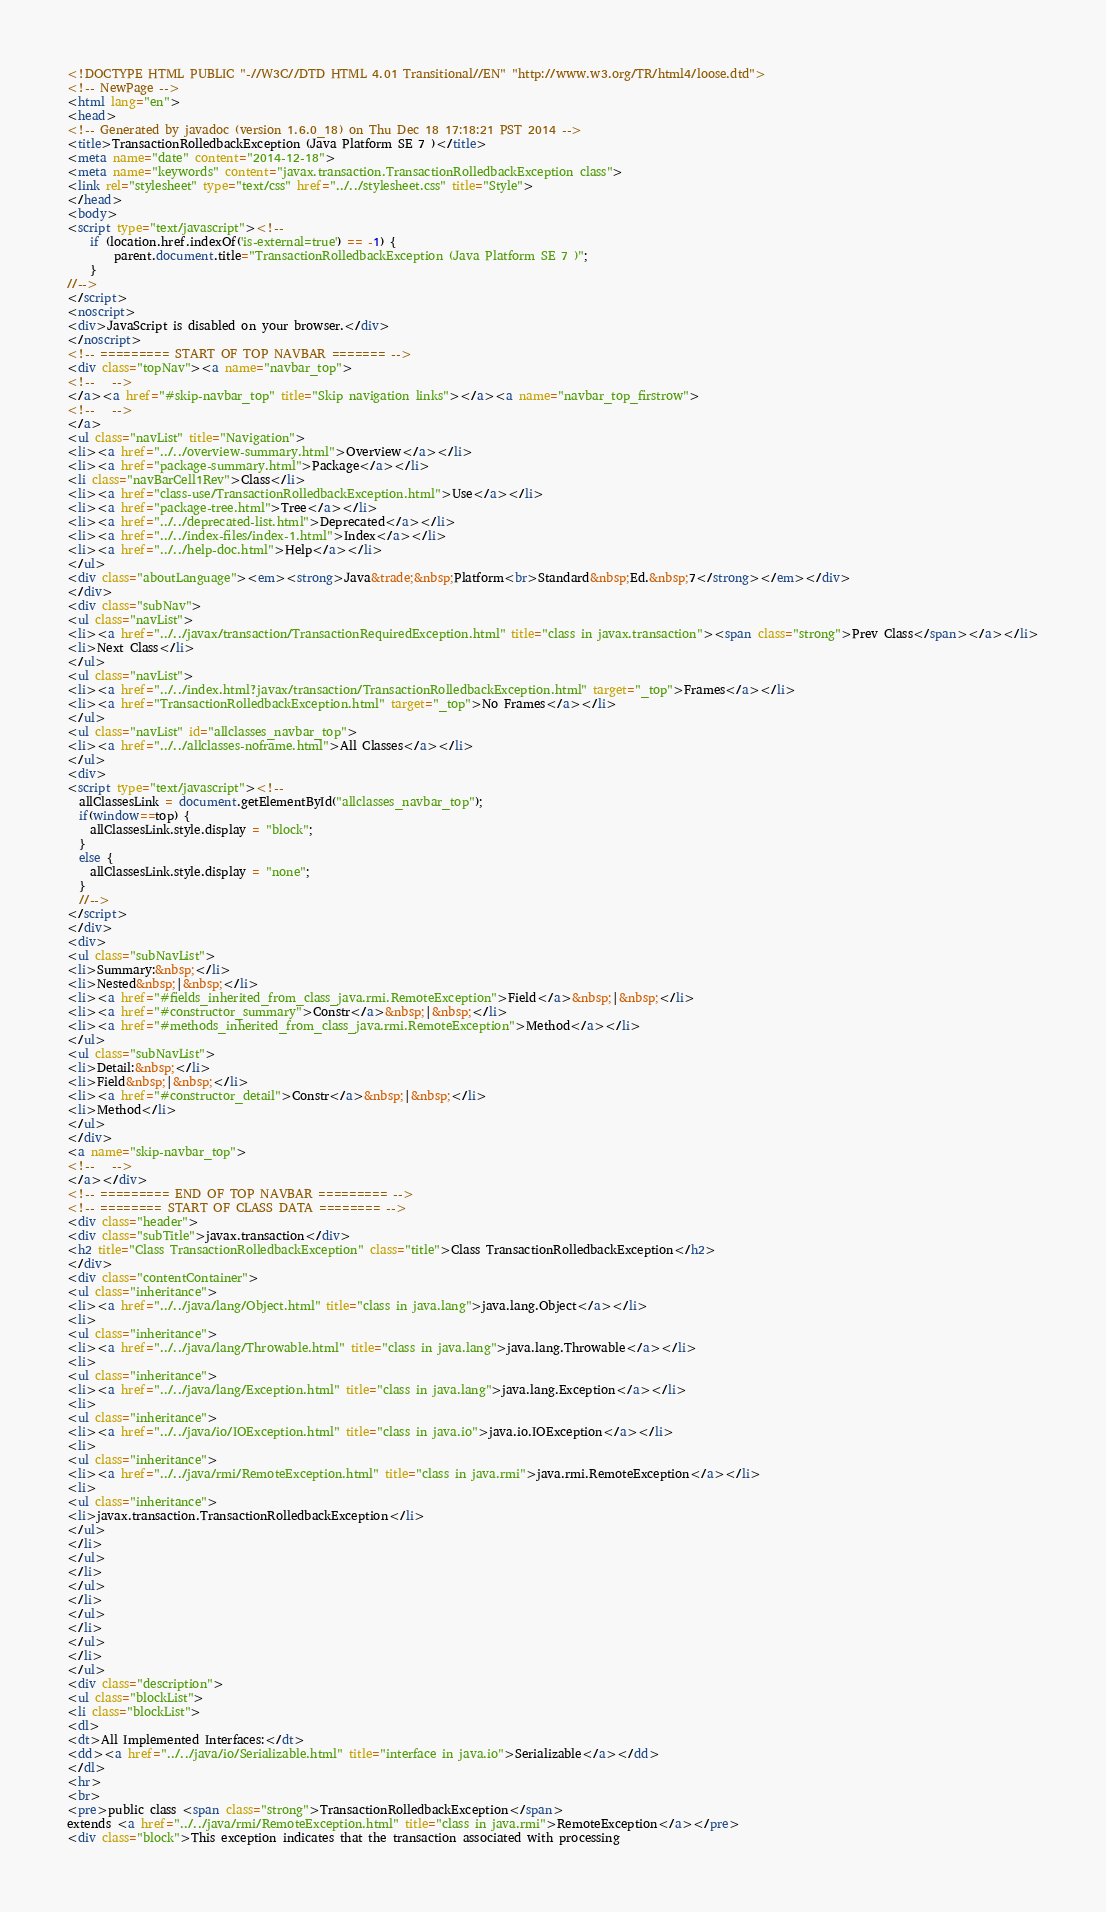Convert code to text. <code><loc_0><loc_0><loc_500><loc_500><_HTML_><!DOCTYPE HTML PUBLIC "-//W3C//DTD HTML 4.01 Transitional//EN" "http://www.w3.org/TR/html4/loose.dtd">
<!-- NewPage -->
<html lang="en">
<head>
<!-- Generated by javadoc (version 1.6.0_18) on Thu Dec 18 17:18:21 PST 2014 -->
<title>TransactionRolledbackException (Java Platform SE 7 )</title>
<meta name="date" content="2014-12-18">
<meta name="keywords" content="javax.transaction.TransactionRolledbackException class">
<link rel="stylesheet" type="text/css" href="../../stylesheet.css" title="Style">
</head>
<body>
<script type="text/javascript"><!--
    if (location.href.indexOf('is-external=true') == -1) {
        parent.document.title="TransactionRolledbackException (Java Platform SE 7 )";
    }
//-->
</script>
<noscript>
<div>JavaScript is disabled on your browser.</div>
</noscript>
<!-- ========= START OF TOP NAVBAR ======= -->
<div class="topNav"><a name="navbar_top">
<!--   -->
</a><a href="#skip-navbar_top" title="Skip navigation links"></a><a name="navbar_top_firstrow">
<!--   -->
</a>
<ul class="navList" title="Navigation">
<li><a href="../../overview-summary.html">Overview</a></li>
<li><a href="package-summary.html">Package</a></li>
<li class="navBarCell1Rev">Class</li>
<li><a href="class-use/TransactionRolledbackException.html">Use</a></li>
<li><a href="package-tree.html">Tree</a></li>
<li><a href="../../deprecated-list.html">Deprecated</a></li>
<li><a href="../../index-files/index-1.html">Index</a></li>
<li><a href="../../help-doc.html">Help</a></li>
</ul>
<div class="aboutLanguage"><em><strong>Java&trade;&nbsp;Platform<br>Standard&nbsp;Ed.&nbsp;7</strong></em></div>
</div>
<div class="subNav">
<ul class="navList">
<li><a href="../../javax/transaction/TransactionRequiredException.html" title="class in javax.transaction"><span class="strong">Prev Class</span></a></li>
<li>Next Class</li>
</ul>
<ul class="navList">
<li><a href="../../index.html?javax/transaction/TransactionRolledbackException.html" target="_top">Frames</a></li>
<li><a href="TransactionRolledbackException.html" target="_top">No Frames</a></li>
</ul>
<ul class="navList" id="allclasses_navbar_top">
<li><a href="../../allclasses-noframe.html">All Classes</a></li>
</ul>
<div>
<script type="text/javascript"><!--
  allClassesLink = document.getElementById("allclasses_navbar_top");
  if(window==top) {
    allClassesLink.style.display = "block";
  }
  else {
    allClassesLink.style.display = "none";
  }
  //-->
</script>
</div>
<div>
<ul class="subNavList">
<li>Summary:&nbsp;</li>
<li>Nested&nbsp;|&nbsp;</li>
<li><a href="#fields_inherited_from_class_java.rmi.RemoteException">Field</a>&nbsp;|&nbsp;</li>
<li><a href="#constructor_summary">Constr</a>&nbsp;|&nbsp;</li>
<li><a href="#methods_inherited_from_class_java.rmi.RemoteException">Method</a></li>
</ul>
<ul class="subNavList">
<li>Detail:&nbsp;</li>
<li>Field&nbsp;|&nbsp;</li>
<li><a href="#constructor_detail">Constr</a>&nbsp;|&nbsp;</li>
<li>Method</li>
</ul>
</div>
<a name="skip-navbar_top">
<!--   -->
</a></div>
<!-- ========= END OF TOP NAVBAR ========= -->
<!-- ======== START OF CLASS DATA ======== -->
<div class="header">
<div class="subTitle">javax.transaction</div>
<h2 title="Class TransactionRolledbackException" class="title">Class TransactionRolledbackException</h2>
</div>
<div class="contentContainer">
<ul class="inheritance">
<li><a href="../../java/lang/Object.html" title="class in java.lang">java.lang.Object</a></li>
<li>
<ul class="inheritance">
<li><a href="../../java/lang/Throwable.html" title="class in java.lang">java.lang.Throwable</a></li>
<li>
<ul class="inheritance">
<li><a href="../../java/lang/Exception.html" title="class in java.lang">java.lang.Exception</a></li>
<li>
<ul class="inheritance">
<li><a href="../../java/io/IOException.html" title="class in java.io">java.io.IOException</a></li>
<li>
<ul class="inheritance">
<li><a href="../../java/rmi/RemoteException.html" title="class in java.rmi">java.rmi.RemoteException</a></li>
<li>
<ul class="inheritance">
<li>javax.transaction.TransactionRolledbackException</li>
</ul>
</li>
</ul>
</li>
</ul>
</li>
</ul>
</li>
</ul>
</li>
</ul>
<div class="description">
<ul class="blockList">
<li class="blockList">
<dl>
<dt>All Implemented Interfaces:</dt>
<dd><a href="../../java/io/Serializable.html" title="interface in java.io">Serializable</a></dd>
</dl>
<hr>
<br>
<pre>public class <span class="strong">TransactionRolledbackException</span>
extends <a href="../../java/rmi/RemoteException.html" title="class in java.rmi">RemoteException</a></pre>
<div class="block">This exception indicates that the transaction associated with processing</code> 